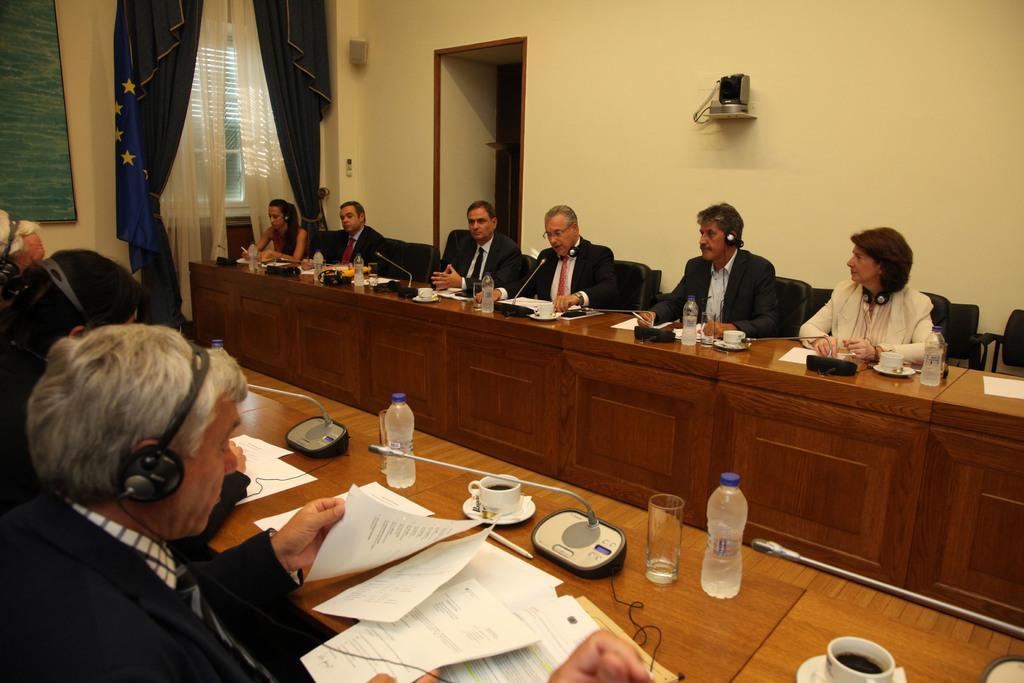Describe this image in one or two sentences. Here we can see some persons are sitting on the chairs. These are the tables. On the table there are paper, cups, glasses, and bottles. On the background there is a wall. This is window and there is a curtain. 